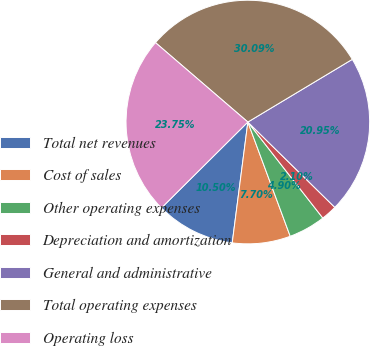<chart> <loc_0><loc_0><loc_500><loc_500><pie_chart><fcel>Total net revenues<fcel>Cost of sales<fcel>Other operating expenses<fcel>Depreciation and amortization<fcel>General and administrative<fcel>Total operating expenses<fcel>Operating loss<nl><fcel>10.5%<fcel>7.7%<fcel>4.9%<fcel>2.1%<fcel>20.95%<fcel>30.09%<fcel>23.75%<nl></chart> 